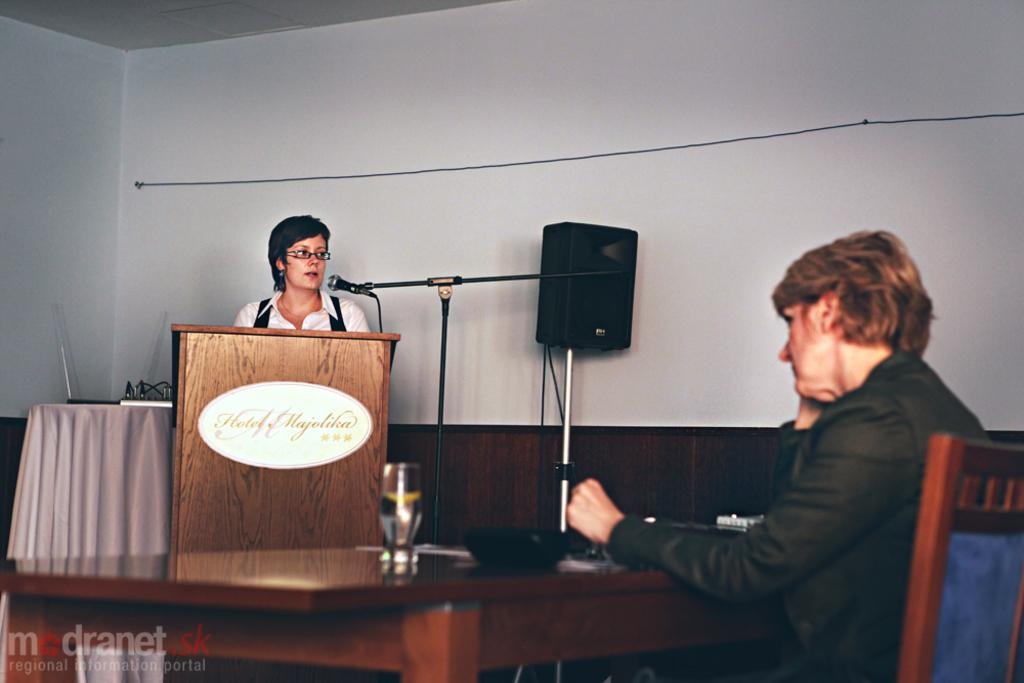What is the woman in the image doing? There is a woman sitting on a chair in the image. What is near the sitting woman? The woman is near a table. What is the other woman in the image doing? There is a woman standing in front of a microphone in the image. Where is the microphone located in relation to the sitting woman? The microphone is on the right side of the sitting woman. What type of tramp can be seen jumping in the background of the image? There is no tramp present in the image, and therefore no such activity can be observed. 